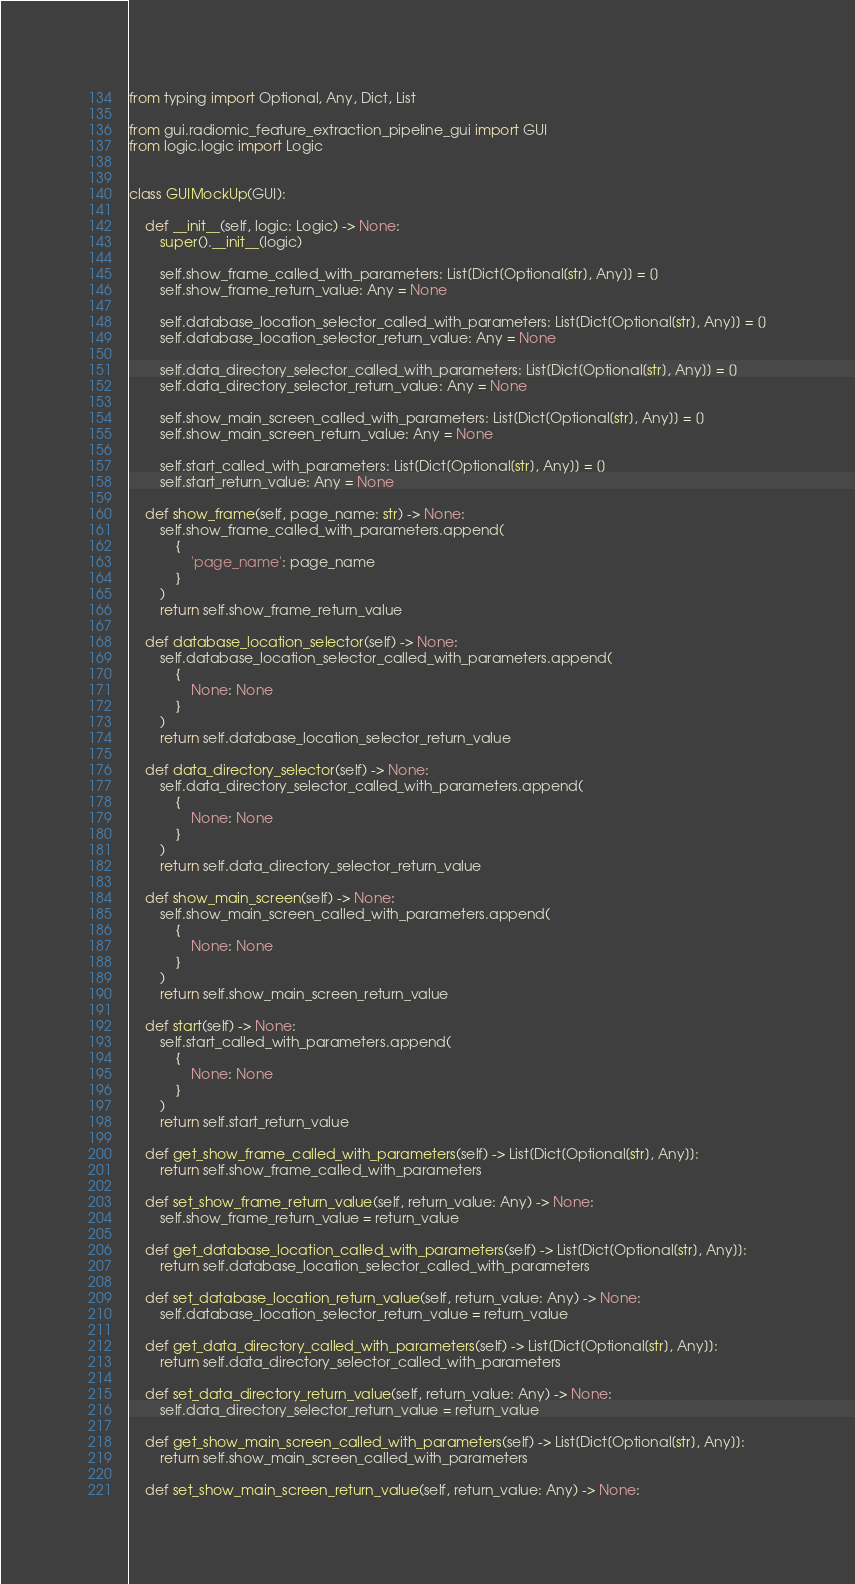<code> <loc_0><loc_0><loc_500><loc_500><_Python_>from typing import Optional, Any, Dict, List

from gui.radiomic_feature_extraction_pipeline_gui import GUI
from logic.logic import Logic


class GUIMockUp(GUI):

    def __init__(self, logic: Logic) -> None:
        super().__init__(logic)

        self.show_frame_called_with_parameters: List[Dict[Optional[str], Any]] = []
        self.show_frame_return_value: Any = None

        self.database_location_selector_called_with_parameters: List[Dict[Optional[str], Any]] = []
        self.database_location_selector_return_value: Any = None

        self.data_directory_selector_called_with_parameters: List[Dict[Optional[str], Any]] = []
        self.data_directory_selector_return_value: Any = None

        self.show_main_screen_called_with_parameters: List[Dict[Optional[str], Any]] = []
        self.show_main_screen_return_value: Any = None

        self.start_called_with_parameters: List[Dict[Optional[str], Any]] = []
        self.start_return_value: Any = None

    def show_frame(self, page_name: str) -> None:
        self.show_frame_called_with_parameters.append(
            {
                'page_name': page_name
            }
        )
        return self.show_frame_return_value

    def database_location_selector(self) -> None:
        self.database_location_selector_called_with_parameters.append(
            {
                None: None
            }
        )
        return self.database_location_selector_return_value

    def data_directory_selector(self) -> None:
        self.data_directory_selector_called_with_parameters.append(
            {
                None: None
            }
        )
        return self.data_directory_selector_return_value

    def show_main_screen(self) -> None:
        self.show_main_screen_called_with_parameters.append(
            {
                None: None
            }
        )
        return self.show_main_screen_return_value

    def start(self) -> None:
        self.start_called_with_parameters.append(
            {
                None: None
            }
        )
        return self.start_return_value

    def get_show_frame_called_with_parameters(self) -> List[Dict[Optional[str], Any]]:
        return self.show_frame_called_with_parameters

    def set_show_frame_return_value(self, return_value: Any) -> None:
        self.show_frame_return_value = return_value

    def get_database_location_called_with_parameters(self) -> List[Dict[Optional[str], Any]]:
        return self.database_location_selector_called_with_parameters

    def set_database_location_return_value(self, return_value: Any) -> None:
        self.database_location_selector_return_value = return_value

    def get_data_directory_called_with_parameters(self) -> List[Dict[Optional[str], Any]]:
        return self.data_directory_selector_called_with_parameters

    def set_data_directory_return_value(self, return_value: Any) -> None:
        self.data_directory_selector_return_value = return_value

    def get_show_main_screen_called_with_parameters(self) -> List[Dict[Optional[str], Any]]:
        return self.show_main_screen_called_with_parameters

    def set_show_main_screen_return_value(self, return_value: Any) -> None:</code> 